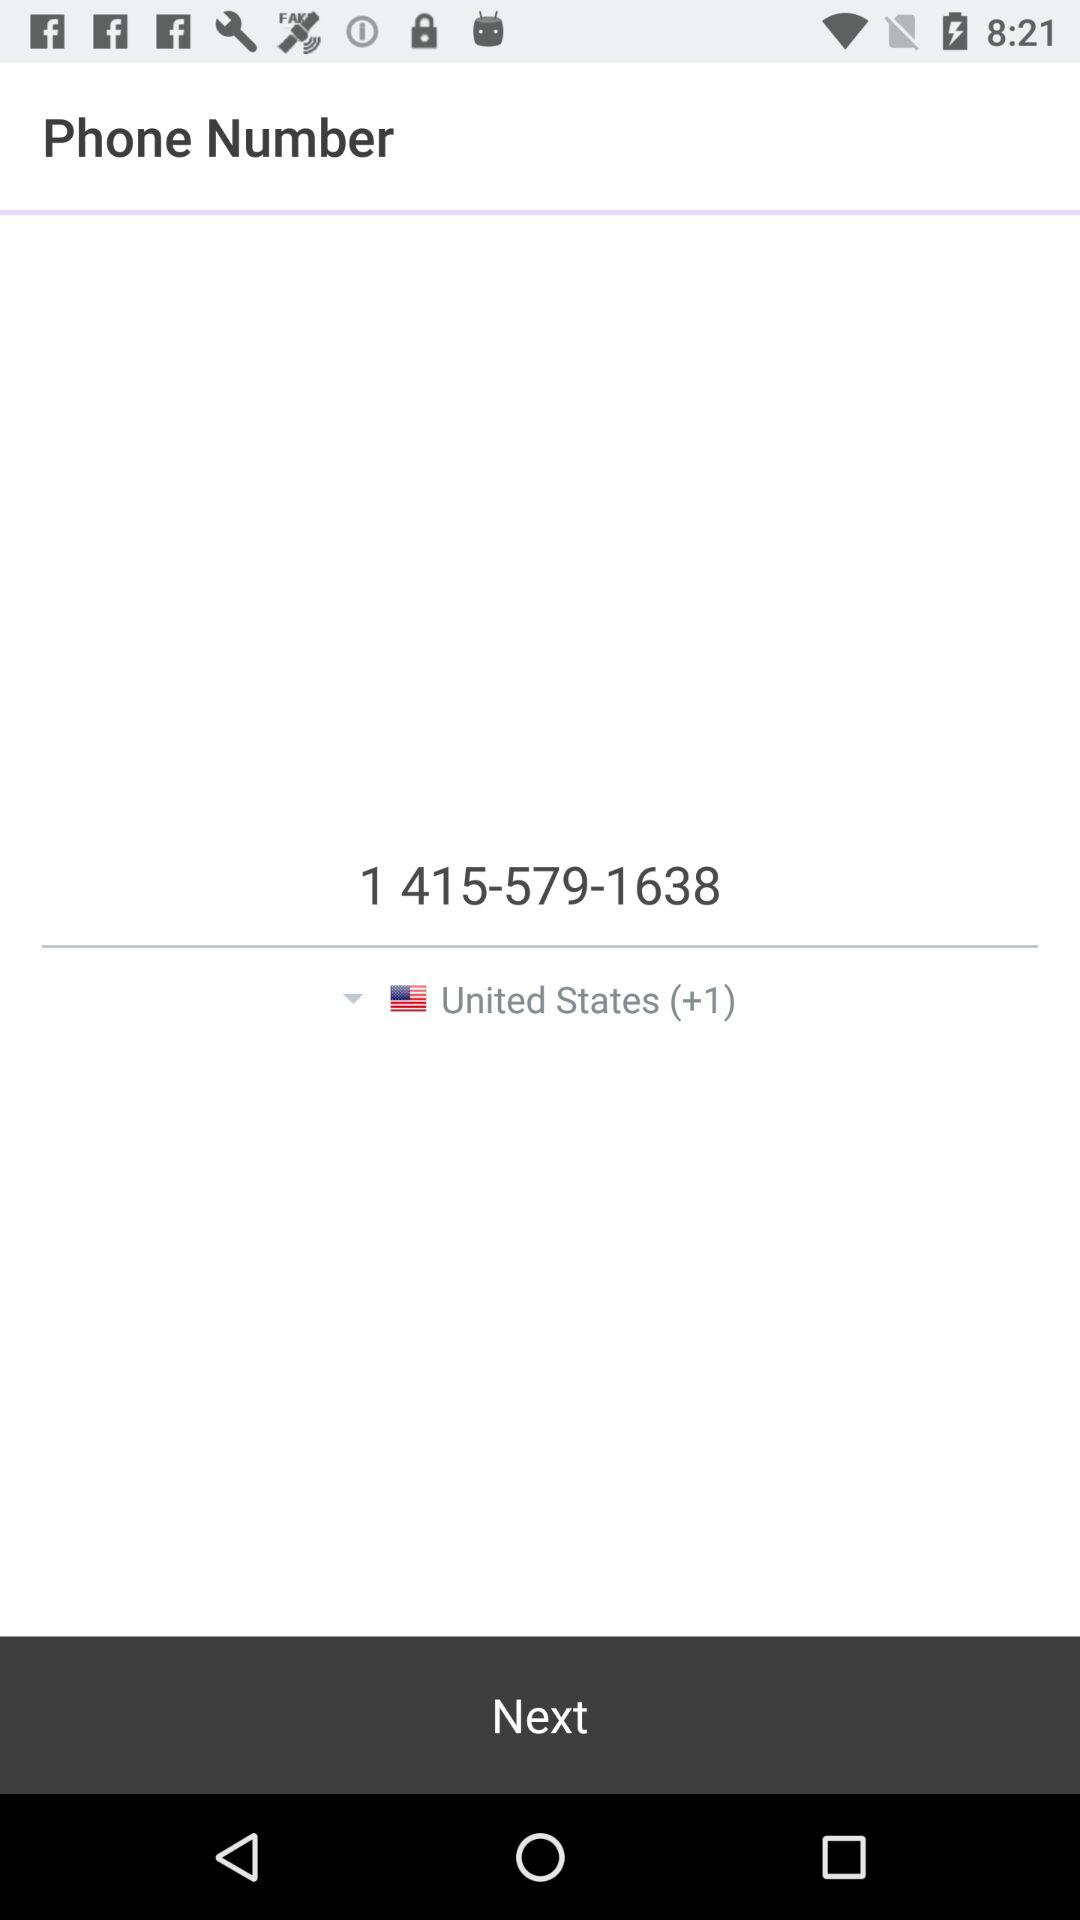What is the contact number? The contact number is 1 415-579-1638. 